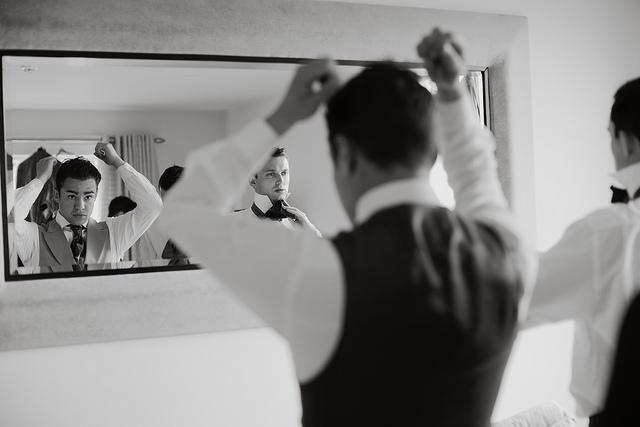Are they going to a formal occasion?
Give a very brief answer. Yes. What is the person pointing at?
Quick response, please. Hair. Is this black and white?
Short answer required. Yes. What are the two men doing?
Concise answer only. Getting ready. Where is the man standing?
Quick response, please. In front of mirror. Is this a man or a woman?
Keep it brief. Man. 